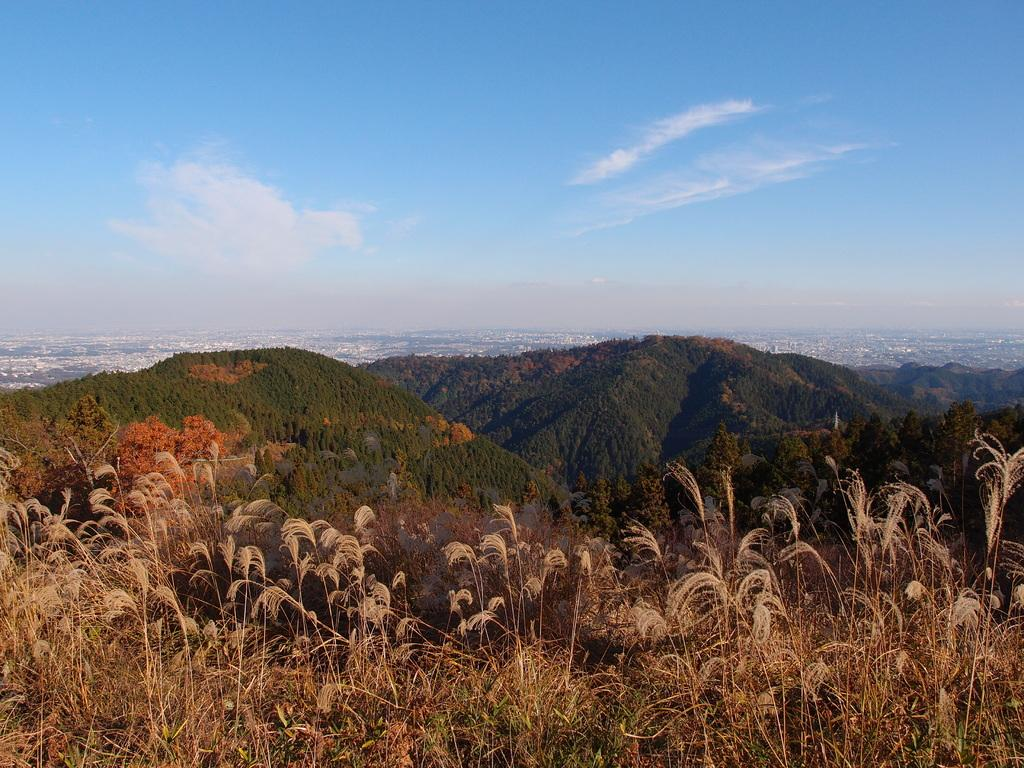What type of vegetation is at the bottom of the image? There is grass at the bottom of the image. What can be seen on the mountains in the image? There are trees on the mountains in the image. What is visible in the background of the image? There are trees, buildings, and clouds in the sky in the background of the image. What type of cloth is being used to generate profit in the image? There is no cloth or profit-generating activity present in the image. How does the bit of information about the trees relate to the profit in the image? There is no mention of a bit of information or profit in the image; it primarily features trees, mountains, grass, buildings, and clouds. 